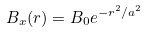Convert formula to latex. <formula><loc_0><loc_0><loc_500><loc_500>B _ { x } ( r ) = B _ { 0 } e ^ { - r ^ { 2 } / a ^ { 2 } }</formula> 